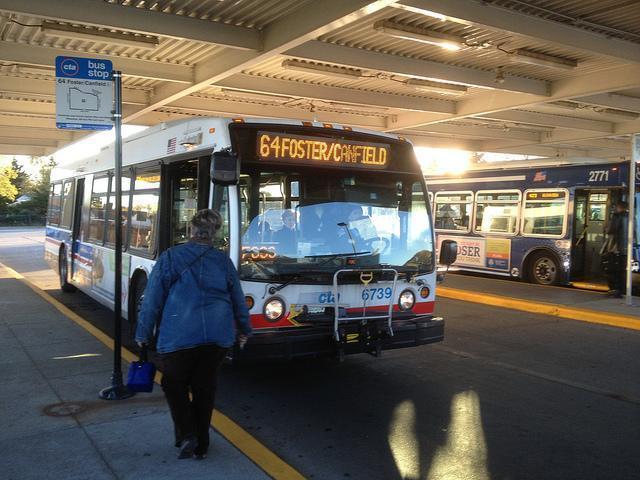How many buses are there?
Give a very brief answer. 2. How many buses can be seen?
Give a very brief answer. 2. How many toilet paper rolls are there?
Give a very brief answer. 0. 